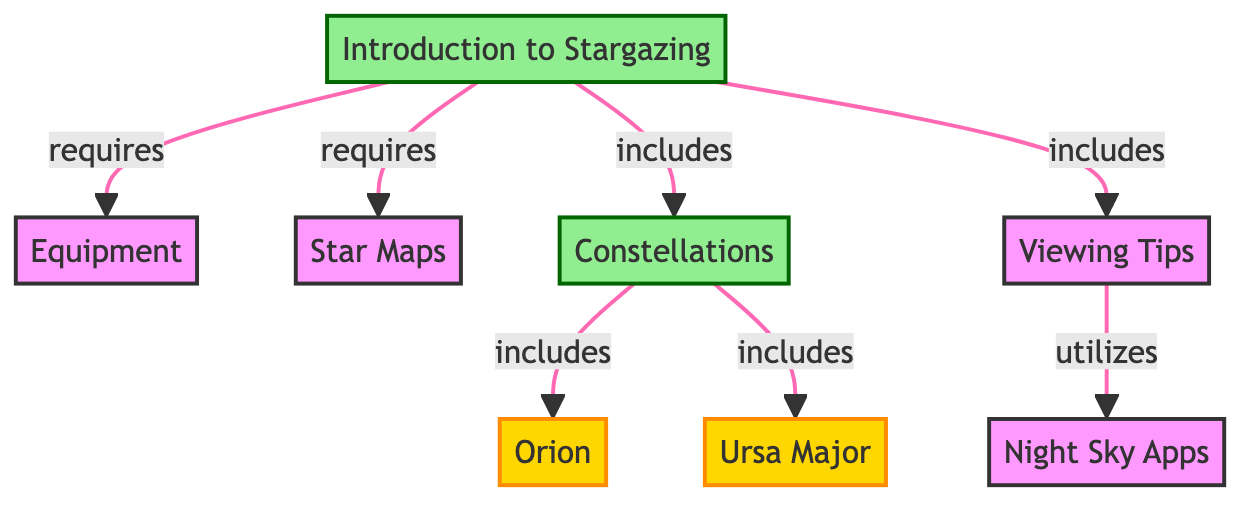What is the node that represents the main starting point of the diagram? The first node is "Introduction to Stargazing," which serves as the root or starting point of the flowchart.
Answer: Introduction to Stargazing How many constellations are included in the diagram? The nodes that represent constellations are "Orion" and "Ursa Major." Thus, there are two constellations shown in the diagram.
Answer: 2 What type of node is "Viewing Tips"? "Viewing Tips" is categorized as a topic node in the diagram, which indicates its importance in the context of the overall subject.
Answer: topic Which equipment is required to start stargazing? According to the diagram, "Equipment" is mentioned as a requirement for the "Introduction to Stargazing," indicating that specific equipment must be used to stargaze properly.
Answer: Equipment Which constellation node is included under the "Constellations" topic? Under the "Constellations" topic, both "Orion" and "Ursa Major" are included, thus representing the visible star patterns discussed.
Answer: Orion, Ursa Major How does "Viewing Tips" utilize "Night Sky Apps"? The diagram indicates an edge labeled "utilizes" between "Viewing Tips" and "Night Sky Apps," suggesting that tips for viewing are enhanced or supported by using these applications.
Answer: Night Sky Apps What are the two main categories of information shown in the diagram? The two main categories are "Constellations" and "Equipment," which represent important elements for stargazing.
Answer: Constellations, Equipment What relationship exists between "Introduction to Stargazing" and "Star Maps"? The diagram shows a direct edge from "Introduction to Stargazing" to "Star Maps," indicating that star maps are a necessary resource when beginning stargazing.
Answer: requires 